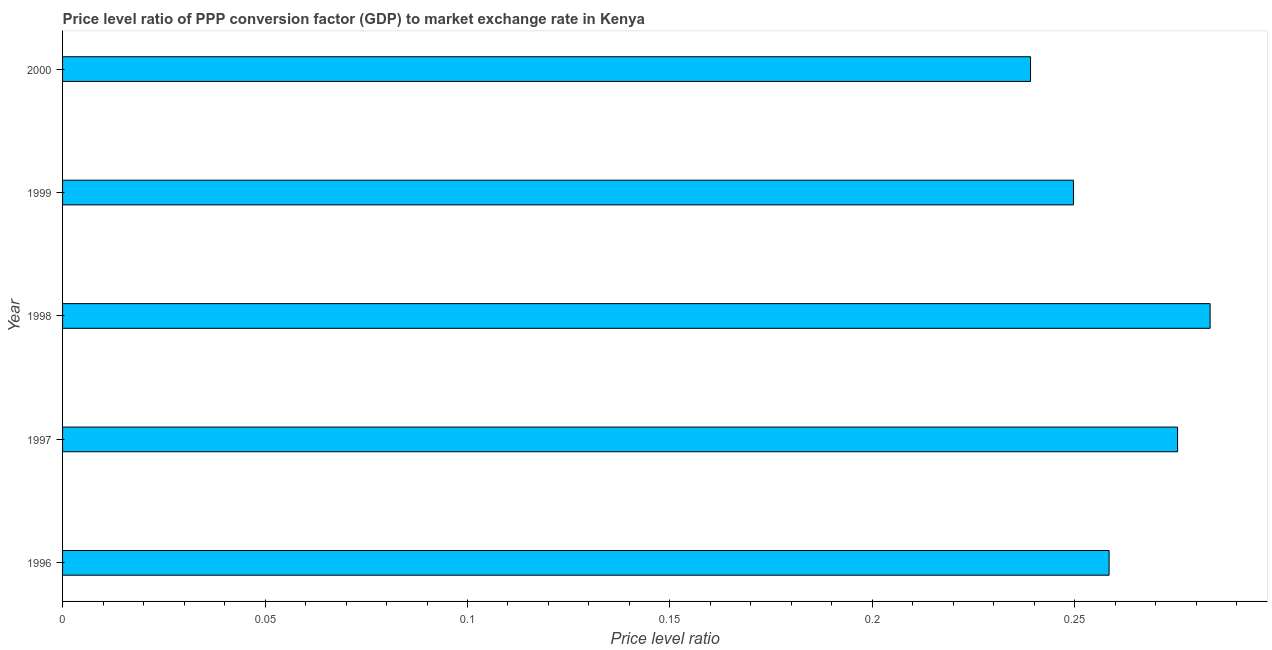Does the graph contain grids?
Keep it short and to the point. No. What is the title of the graph?
Give a very brief answer. Price level ratio of PPP conversion factor (GDP) to market exchange rate in Kenya. What is the label or title of the X-axis?
Provide a succinct answer. Price level ratio. What is the price level ratio in 2000?
Your answer should be compact. 0.24. Across all years, what is the maximum price level ratio?
Keep it short and to the point. 0.28. Across all years, what is the minimum price level ratio?
Keep it short and to the point. 0.24. What is the sum of the price level ratio?
Make the answer very short. 1.31. What is the difference between the price level ratio in 1997 and 1999?
Offer a terse response. 0.03. What is the average price level ratio per year?
Provide a short and direct response. 0.26. What is the median price level ratio?
Your answer should be compact. 0.26. In how many years, is the price level ratio greater than 0.09 ?
Your response must be concise. 5. Do a majority of the years between 2000 and 1996 (inclusive) have price level ratio greater than 0.21 ?
Offer a terse response. Yes. What is the ratio of the price level ratio in 1998 to that in 1999?
Give a very brief answer. 1.14. Is the price level ratio in 1997 less than that in 1998?
Keep it short and to the point. Yes. Is the difference between the price level ratio in 1997 and 1998 greater than the difference between any two years?
Ensure brevity in your answer.  No. What is the difference between the highest and the second highest price level ratio?
Provide a short and direct response. 0.01. Is the sum of the price level ratio in 1996 and 1999 greater than the maximum price level ratio across all years?
Give a very brief answer. Yes. Are all the bars in the graph horizontal?
Offer a terse response. Yes. What is the difference between two consecutive major ticks on the X-axis?
Provide a short and direct response. 0.05. Are the values on the major ticks of X-axis written in scientific E-notation?
Ensure brevity in your answer.  No. What is the Price level ratio in 1996?
Your answer should be compact. 0.26. What is the Price level ratio of 1997?
Your answer should be compact. 0.28. What is the Price level ratio of 1998?
Your response must be concise. 0.28. What is the Price level ratio of 1999?
Your response must be concise. 0.25. What is the Price level ratio in 2000?
Offer a terse response. 0.24. What is the difference between the Price level ratio in 1996 and 1997?
Make the answer very short. -0.02. What is the difference between the Price level ratio in 1996 and 1998?
Ensure brevity in your answer.  -0.02. What is the difference between the Price level ratio in 1996 and 1999?
Offer a very short reply. 0.01. What is the difference between the Price level ratio in 1996 and 2000?
Ensure brevity in your answer.  0.02. What is the difference between the Price level ratio in 1997 and 1998?
Ensure brevity in your answer.  -0.01. What is the difference between the Price level ratio in 1997 and 1999?
Your answer should be compact. 0.03. What is the difference between the Price level ratio in 1997 and 2000?
Ensure brevity in your answer.  0.04. What is the difference between the Price level ratio in 1998 and 1999?
Your answer should be compact. 0.03. What is the difference between the Price level ratio in 1998 and 2000?
Keep it short and to the point. 0.04. What is the difference between the Price level ratio in 1999 and 2000?
Offer a terse response. 0.01. What is the ratio of the Price level ratio in 1996 to that in 1997?
Provide a short and direct response. 0.94. What is the ratio of the Price level ratio in 1996 to that in 1998?
Keep it short and to the point. 0.91. What is the ratio of the Price level ratio in 1996 to that in 1999?
Offer a terse response. 1.03. What is the ratio of the Price level ratio in 1996 to that in 2000?
Keep it short and to the point. 1.08. What is the ratio of the Price level ratio in 1997 to that in 1999?
Offer a very short reply. 1.1. What is the ratio of the Price level ratio in 1997 to that in 2000?
Provide a short and direct response. 1.15. What is the ratio of the Price level ratio in 1998 to that in 1999?
Offer a terse response. 1.14. What is the ratio of the Price level ratio in 1998 to that in 2000?
Offer a very short reply. 1.19. What is the ratio of the Price level ratio in 1999 to that in 2000?
Your answer should be compact. 1.04. 